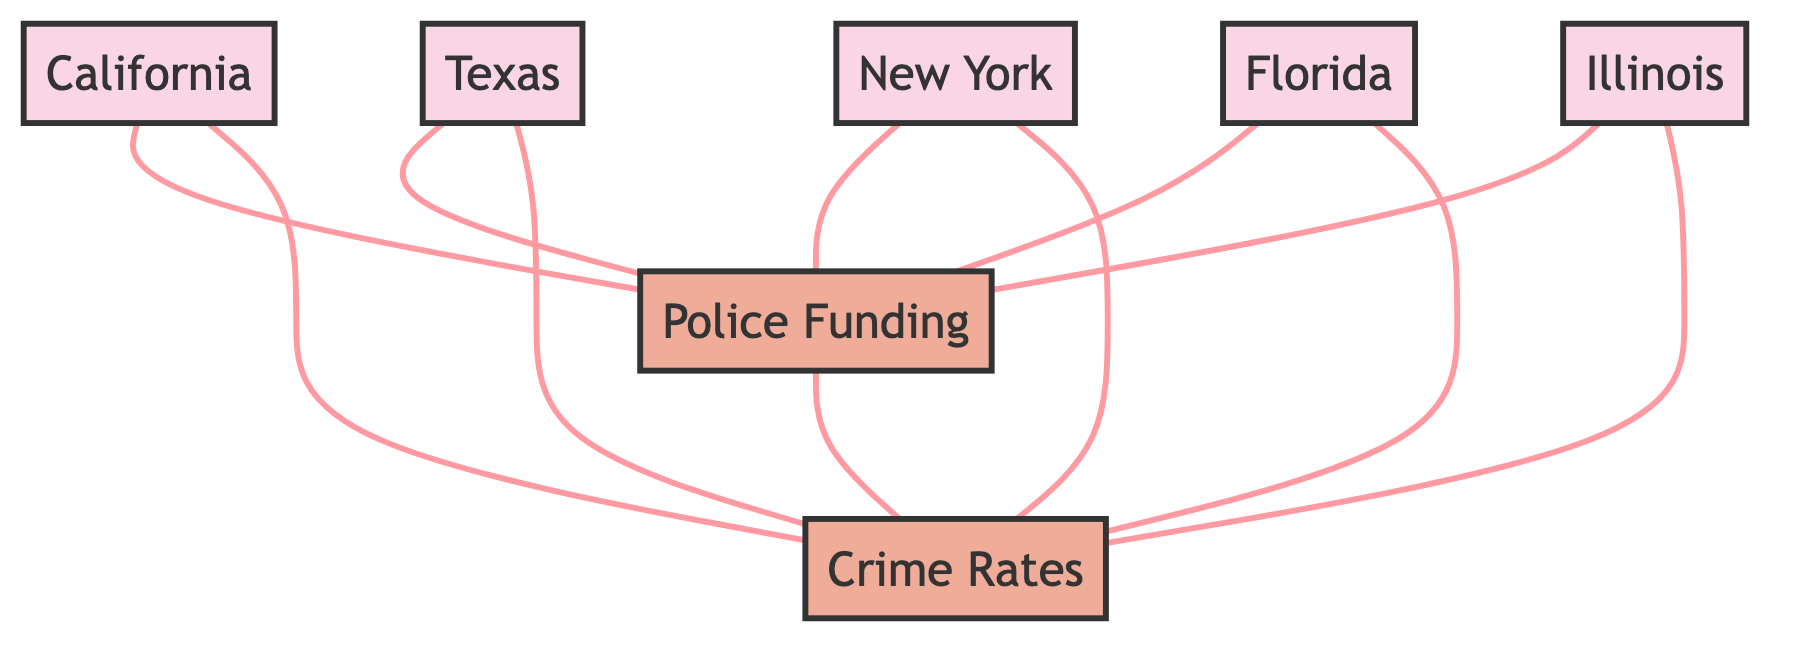What states are connected to Police Funding? By examining the edges connected to the node representing Police Funding, we can identify that California, Texas, New York, Florida, and Illinois are all directly connected to it.
Answer: California, Texas, New York, Florida, Illinois How many nodes are in the diagram? The diagram includes a total of 6 nodes: 5 states and 2 metrics (Police Funding and Crime Rates). Thus, the count is 6.
Answer: 6 Which two nodes have a direct connection to both Police Funding and Crime Rates? The edges reveal that all states (California, Texas, New York, Florida, Illinois) are connected to both Police Funding and Crime Rates. Thus, each state has this direct connection.
Answer: California, Texas, New York, Florida, Illinois What type of graph is represented here? The diagram structure emphasizes mutual connections without directionality, which is characteristic of an undirected graph. Therefore, the type is an undirected graph.
Answer: Undirected Graph Which metric connects directly to each state? All states are connected to the metrics, however, the specific metric for each one is the same: Police Funding and Crime Rates connect to every state listed.
Answer: Police Funding, Crime Rates How many edges are connected to the Crime Rates node? Crime Rates has edges connected to it from each of the five states and also has a direct connection to the Police Funding node, leading to a total of 6 edges.
Answer: 6 Which state has a node linked to both metrics? Each state (California, Texas, New York, Florida, Illinois) is linked to both Police Funding and Crime Rates, as seen from the edges extending from the state nodes to both metric nodes.
Answer: California, Texas, New York, Florida, Illinois Is there a direct connection between Police Funding and Crime Rates? Yes, there is a direct connection as evidenced by the edge that connects these two metrics in the diagram, indicating a clear relationship between them.
Answer: Yes 